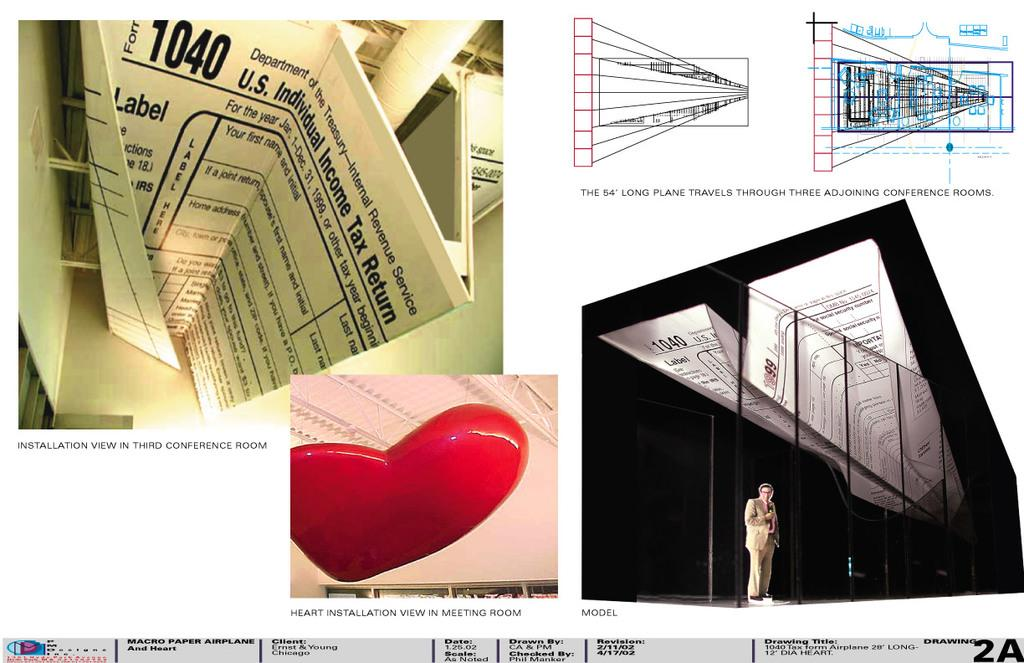Provide a one-sentence caption for the provided image. A paper airplane made out of a 1040 United States tax form. 